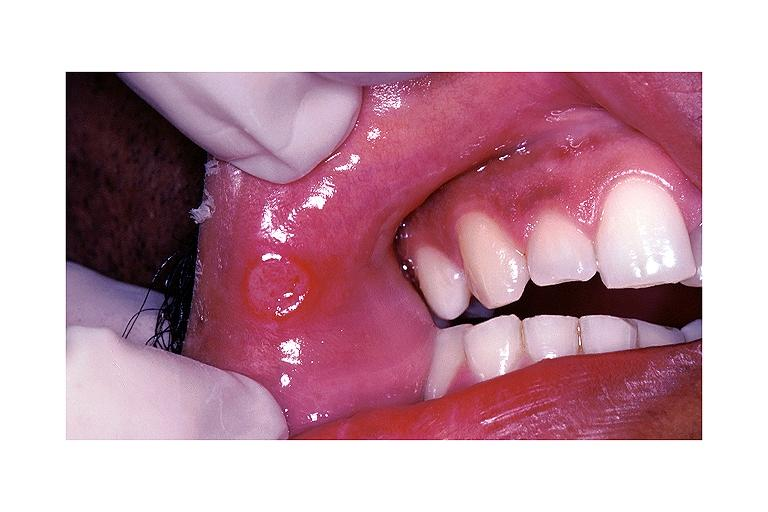does meningitis acute show aphthous ulcer?
Answer the question using a single word or phrase. No 